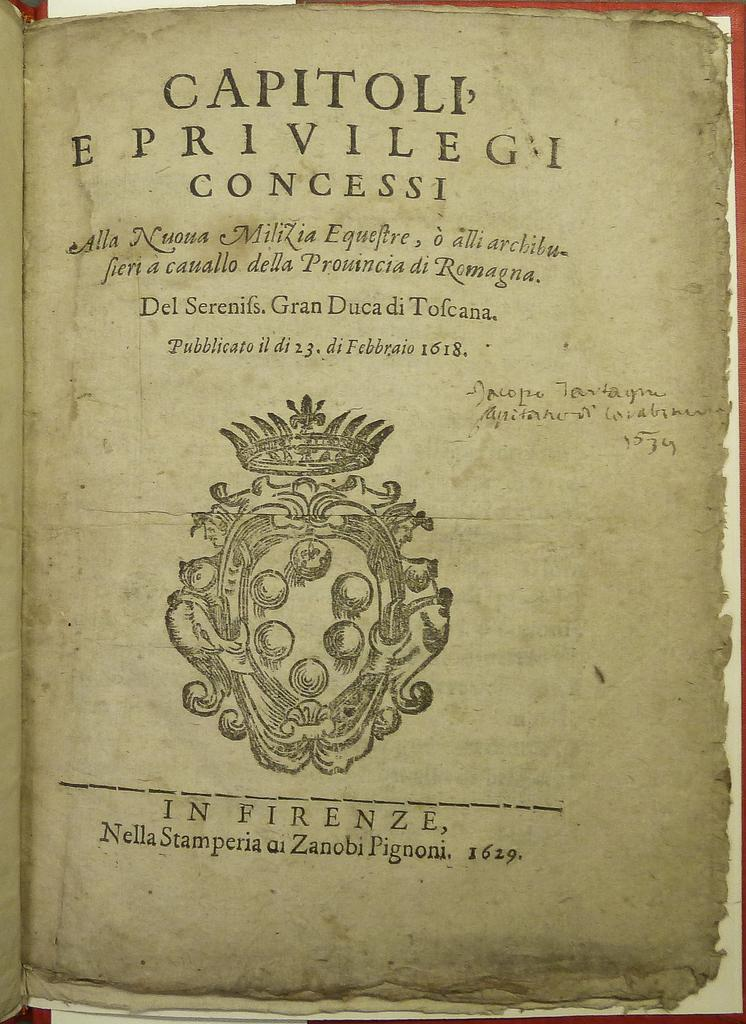What type of paper is shown in the image? The image is of a paper from a book. What information can be found on the paper? The name of the book is present on the paper, as well as a logo and words. What type of ice can be seen in the glass on the paper? There is no ice or glass present in the image; it is a paper from a book with a logo, words, and the book's name. 